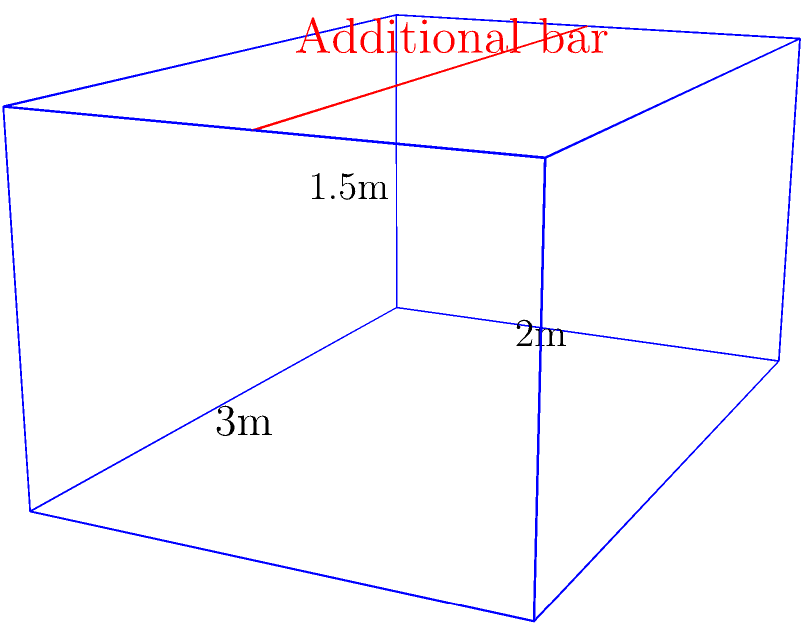As the safety officer for a racing team, you're tasked with calculating the surface area of a new roll cage design. The main structure is a rectangular prism measuring 3m long, 2m wide, and 1.5m high. An additional reinforcement bar runs along the top, parallel to the length. If the bar has a negligible thickness, what is the total surface area of the roll cage in square meters? Let's approach this step-by-step:

1) First, calculate the surface area of the rectangular prism:
   - Front and back: $2 \times (2\text{m} \times 1.5\text{m}) = 6\text{m}^2$
   - Left and right sides: $2 \times (3\text{m} \times 1.5\text{m}) = 9\text{m}^2$
   - Top and bottom: $2 \times (3\text{m} \times 2\text{m}) = 12\text{m}^2$
   
   Total for prism: $6 + 9 + 12 = 27\text{m}^2$

2) The additional bar doesn't add surface area to the top, but it does create two new rectangular surfaces:
   - Each new surface: $3\text{m} \times 1.5\text{m} = 4.5\text{m}^2$
   - Total for both surfaces: $2 \times 4.5\text{m}^2 = 9\text{m}^2$

3) Total surface area:
   $27\text{m}^2 + 9\text{m}^2 = 36\text{m}^2$

Therefore, the total surface area of the roll cage is 36 square meters.
Answer: $36\text{m}^2$ 